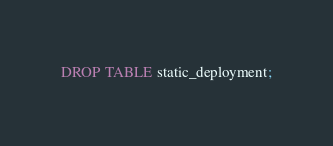<code> <loc_0><loc_0><loc_500><loc_500><_SQL_>DROP TABLE static_deployment;
</code> 